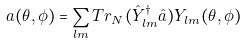Convert formula to latex. <formula><loc_0><loc_0><loc_500><loc_500>a ( \theta , \phi ) = \sum _ { l m } T r _ { N } ( \hat { Y } ^ { \dag } _ { l m } \hat { a } ) Y _ { l m } ( \theta , \phi )</formula> 